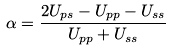Convert formula to latex. <formula><loc_0><loc_0><loc_500><loc_500>\alpha = \frac { 2 U _ { p s } - U _ { p p } - U _ { s s } } { U _ { p p } + U _ { s s } }</formula> 